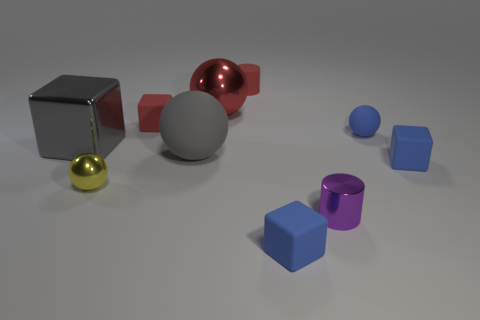Does the small matte cylinder have the same color as the large shiny ball?
Provide a succinct answer. Yes. Is there a gray metal thing of the same shape as the large red thing?
Your answer should be compact. No. There is a small block that is the same color as the tiny rubber cylinder; what is it made of?
Keep it short and to the point. Rubber. What number of shiny things are either small blue things or tiny balls?
Your answer should be compact. 1. The gray matte object is what shape?
Offer a terse response. Sphere. How many large objects are the same material as the yellow ball?
Ensure brevity in your answer.  2. There is a sphere that is the same material as the small yellow thing; what color is it?
Your response must be concise. Red. There is a gray thing that is on the right side of the red block; is its size the same as the gray metal cube?
Keep it short and to the point. Yes. There is a large rubber object that is the same shape as the big red metal object; what color is it?
Keep it short and to the point. Gray. What is the shape of the metallic thing to the right of the rubber block that is in front of the yellow metallic object in front of the large matte ball?
Provide a short and direct response. Cylinder. 